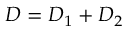<formula> <loc_0><loc_0><loc_500><loc_500>D = D _ { 1 } + D _ { 2 }</formula> 